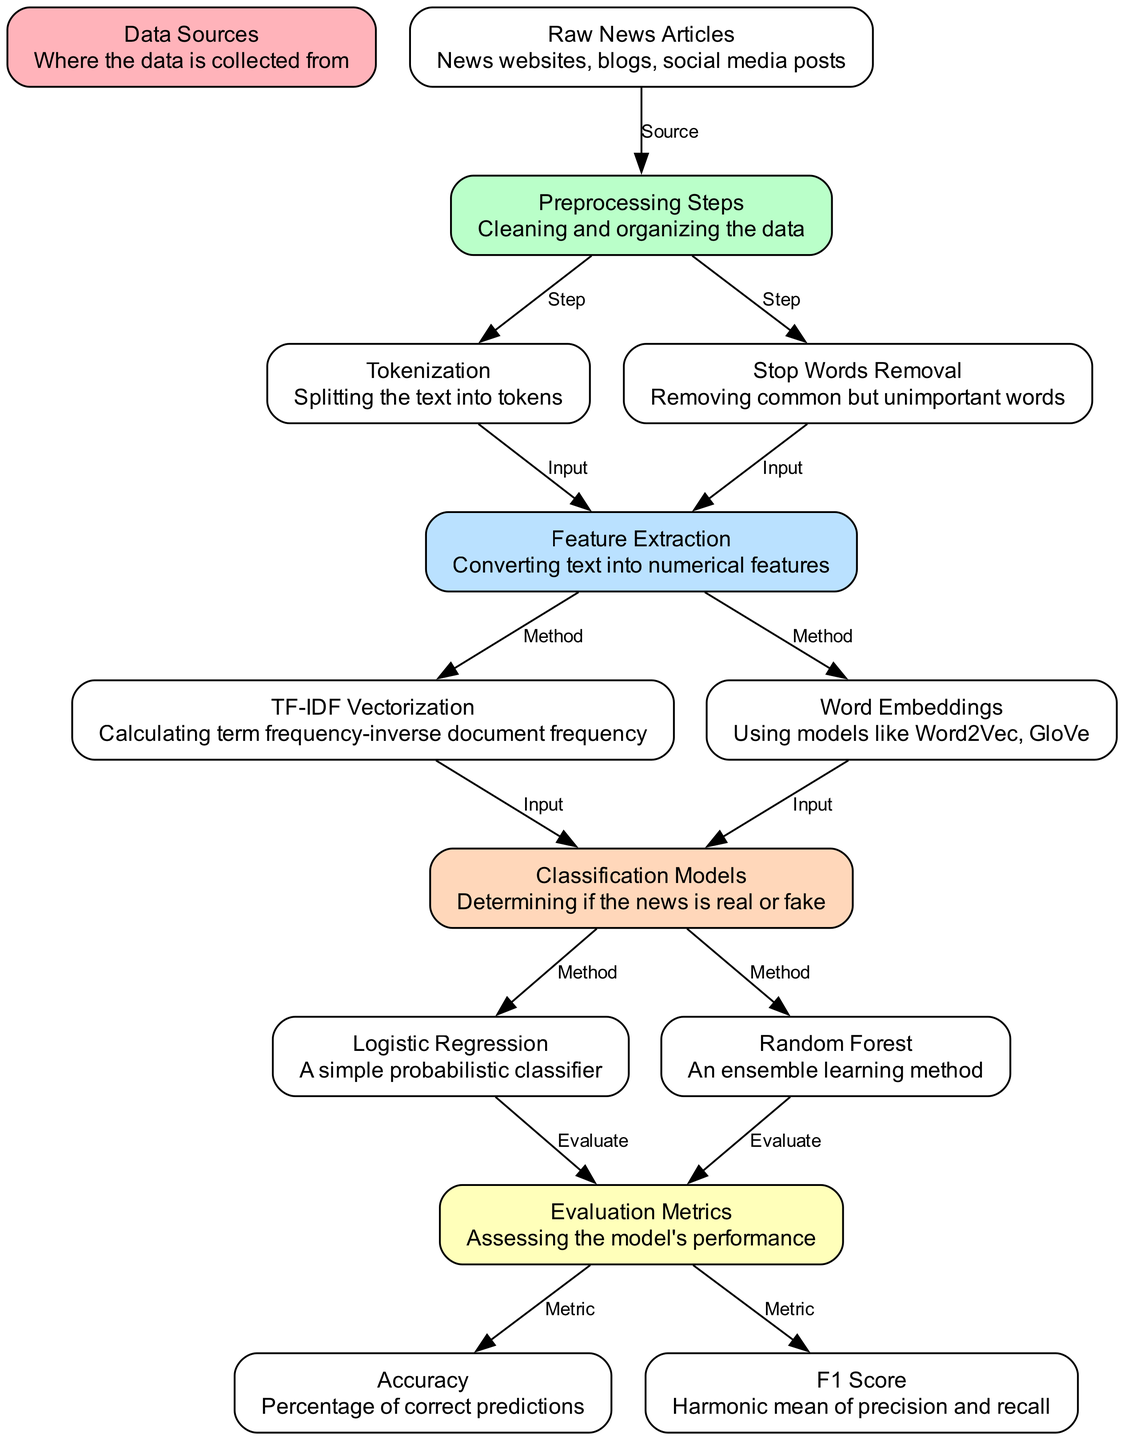What is the first step in the diagram? The first step in the diagram is labeled as "Raw News Articles," which represents the source of the data collected from various platforms.
Answer: Raw News Articles How many classification models does the diagram include? The diagram includes two classification models: Logistic Regression and Random Forest, indicated as separate nodes in the diagram.
Answer: Two What does TF-IDF stand for? TF-IDF stands for "Term Frequency-Inverse Document Frequency," as described in the feature extraction section of the diagram.
Answer: Term Frequency-Inverse Document Frequency What is required for feature extraction? For feature extraction, both tokenization and stop words removal are inputs, as shown by the flow from these nodes to the feature extraction node.
Answer: Tokenization and Stop Words Removal Which model is described as an ensemble learning method? The model described as an ensemble learning method is "Random Forest," indicated by its corresponding node in the diagram.
Answer: Random Forest Which evaluation metric measures the harmonic mean of precision and recall? The evaluation metric that measures the harmonic mean of precision and recall is the "F1 Score," as stated in the evaluation metrics section.
Answer: F1 Score What process comes after preprocessing steps? After preprocessing steps, the next process is feature extraction, as shown by the direct flow from the preprocessing steps node to the feature extraction node.
Answer: Feature Extraction What data sources are mentioned for collecting raw news articles? The data sources mentioned for collecting raw news articles include news websites, blogs, and social media posts, as described in that node.
Answer: News websites, blogs, social media posts Which two methods are used for feature extraction? The two methods used for feature extraction are TF-IDF Vectorization and Word Embeddings, both indicated in the feature extraction section of the diagram.
Answer: TF-IDF Vectorization and Word Embeddings 